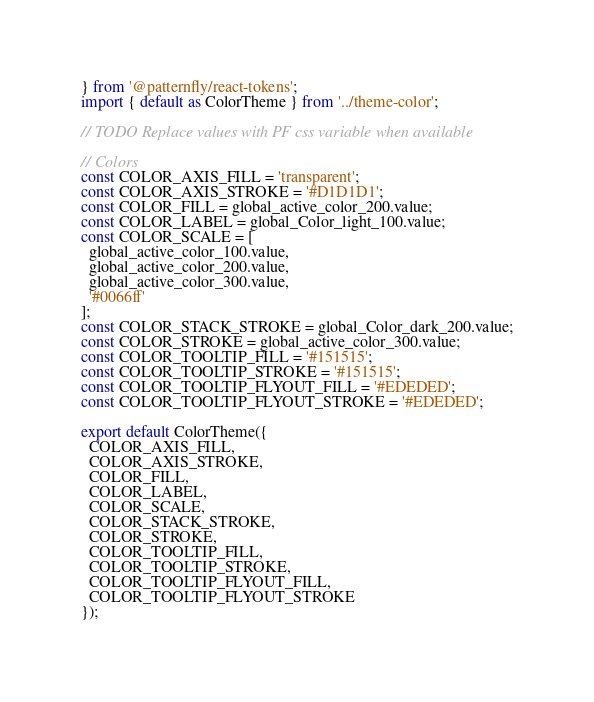Convert code to text. <code><loc_0><loc_0><loc_500><loc_500><_JavaScript_>} from '@patternfly/react-tokens';
import { default as ColorTheme } from '../theme-color';

// TODO Replace values with PF css variable when available

// Colors
const COLOR_AXIS_FILL = 'transparent';
const COLOR_AXIS_STROKE = '#D1D1D1';
const COLOR_FILL = global_active_color_200.value;
const COLOR_LABEL = global_Color_light_100.value;
const COLOR_SCALE = [
  global_active_color_100.value,
  global_active_color_200.value,
  global_active_color_300.value,
  '#0066ff'
];
const COLOR_STACK_STROKE = global_Color_dark_200.value;
const COLOR_STROKE = global_active_color_300.value;
const COLOR_TOOLTIP_FILL = '#151515';
const COLOR_TOOLTIP_STROKE = '#151515';
const COLOR_TOOLTIP_FLYOUT_FILL = '#EDEDED';
const COLOR_TOOLTIP_FLYOUT_STROKE = '#EDEDED';

export default ColorTheme({
  COLOR_AXIS_FILL,
  COLOR_AXIS_STROKE,
  COLOR_FILL,
  COLOR_LABEL,
  COLOR_SCALE,
  COLOR_STACK_STROKE,
  COLOR_STROKE,
  COLOR_TOOLTIP_FILL,
  COLOR_TOOLTIP_STROKE,
  COLOR_TOOLTIP_FLYOUT_FILL,
  COLOR_TOOLTIP_FLYOUT_STROKE
});
</code> 